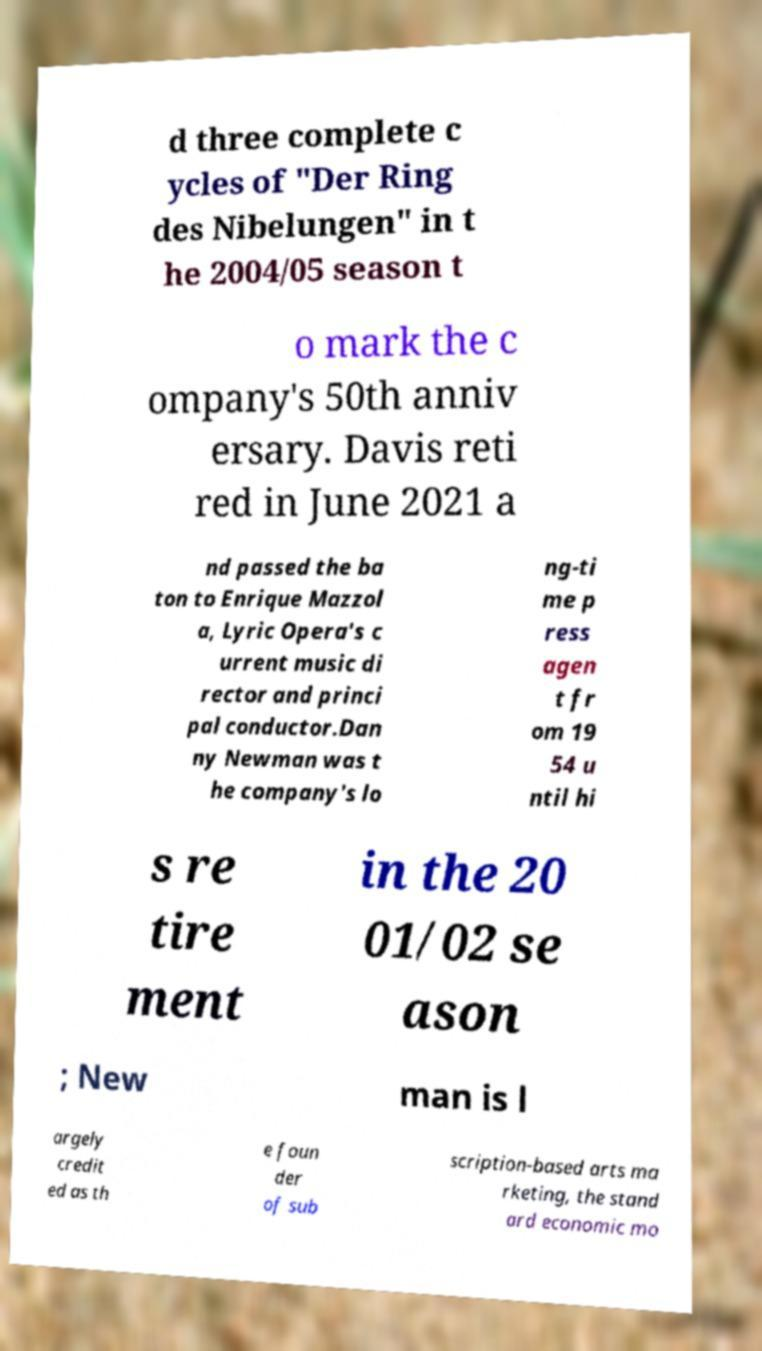Please read and relay the text visible in this image. What does it say? d three complete c ycles of "Der Ring des Nibelungen" in t he 2004/05 season t o mark the c ompany's 50th anniv ersary. Davis reti red in June 2021 a nd passed the ba ton to Enrique Mazzol a, Lyric Opera's c urrent music di rector and princi pal conductor.Dan ny Newman was t he company's lo ng-ti me p ress agen t fr om 19 54 u ntil hi s re tire ment in the 20 01/02 se ason ; New man is l argely credit ed as th e foun der of sub scription-based arts ma rketing, the stand ard economic mo 